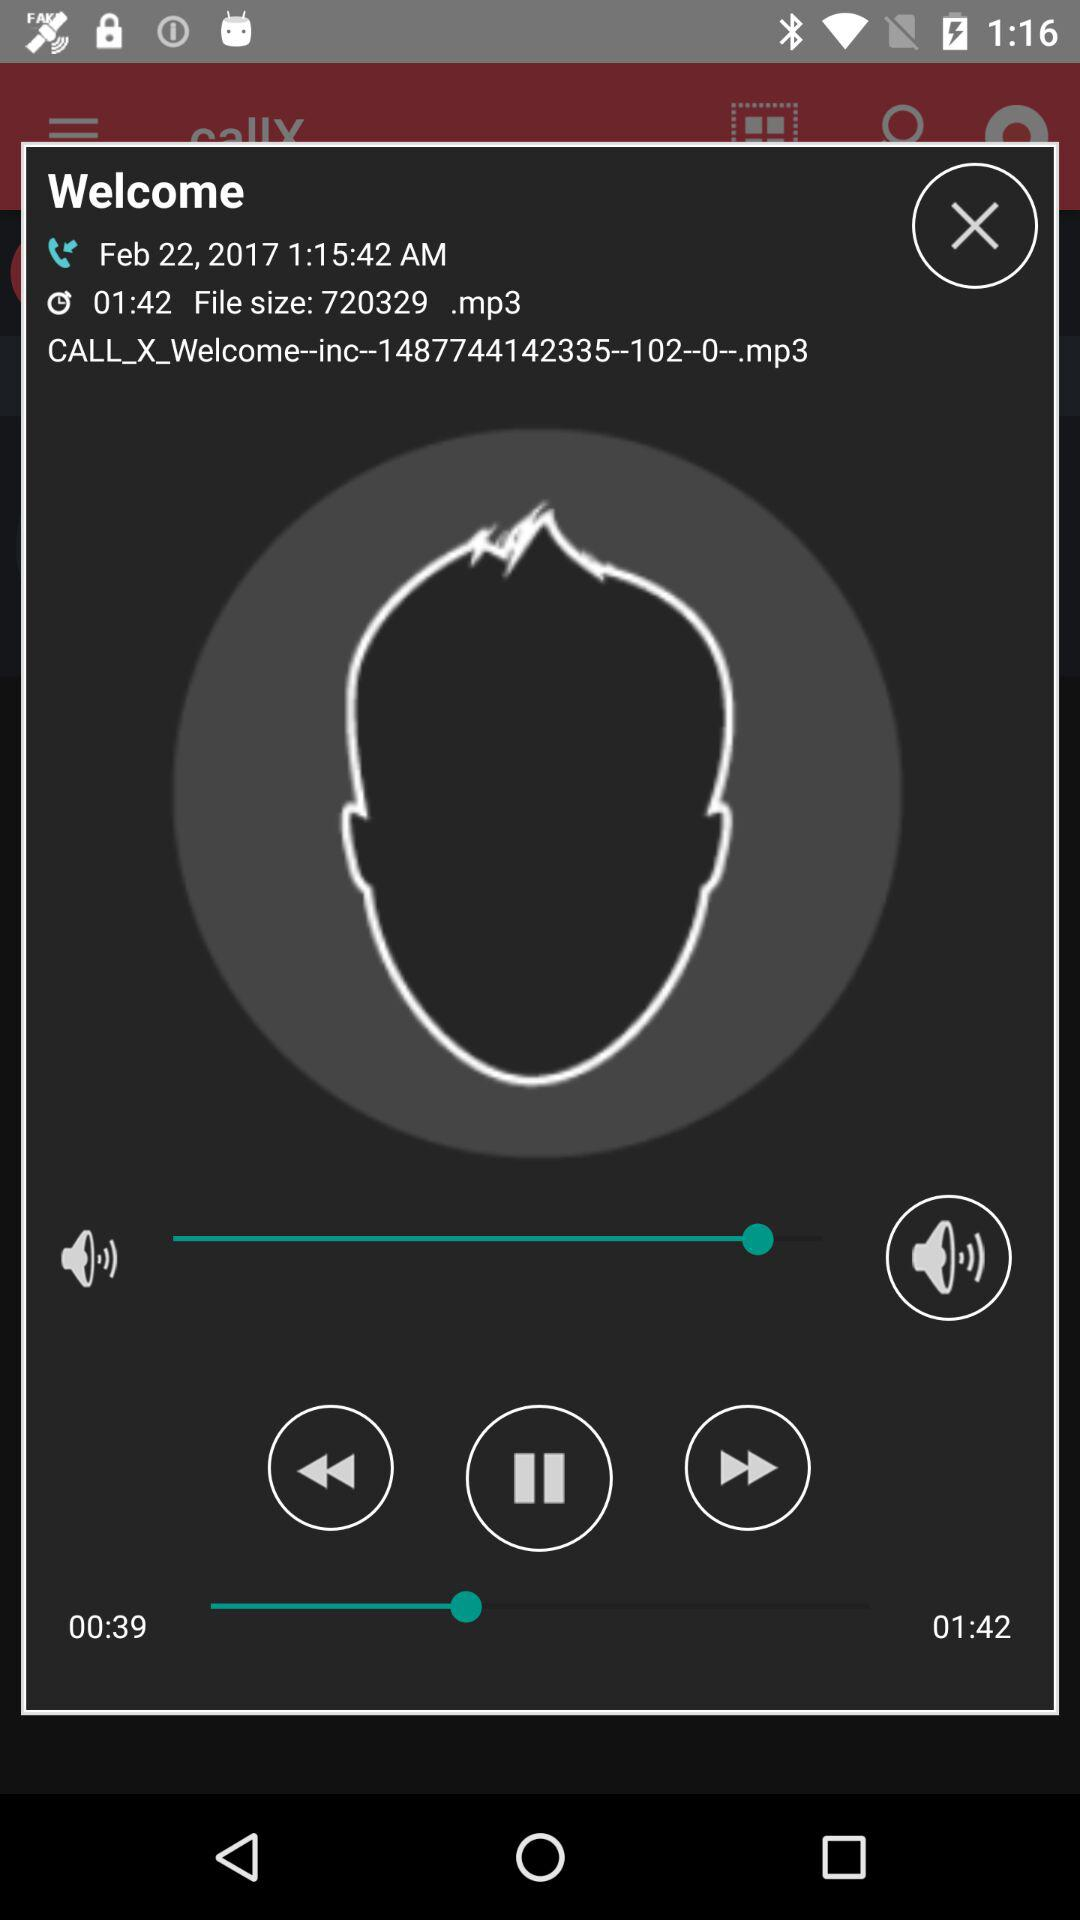What is the time of call recording? The time of the call recording is 1:15:42 AM. 